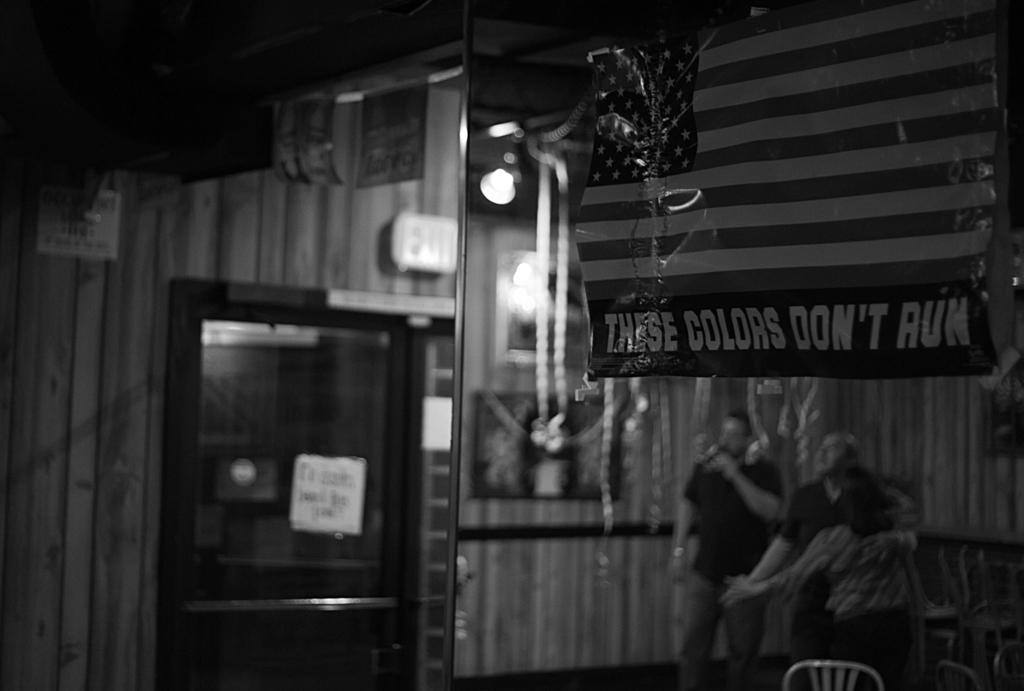What is the color scheme of the image? The image is black and white. Can you describe the background of the image? The background is blurred. Are there any people in the image? Yes, there are people in the image. What else can be seen in the image besides people? There are posters, a signboard, chairs, and other unspecified things in the image. Where is the faucet located in the image? There is no faucet present in the image. What action are the people in the image performing? The provided facts do not specify any actions being performed by the people in the image. 